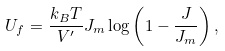<formula> <loc_0><loc_0><loc_500><loc_500>U _ { f } = \frac { k _ { B } T } { V ^ { \prime } } J _ { m } \log \left ( 1 - \frac { J } { J _ { m } } \right ) ,</formula> 